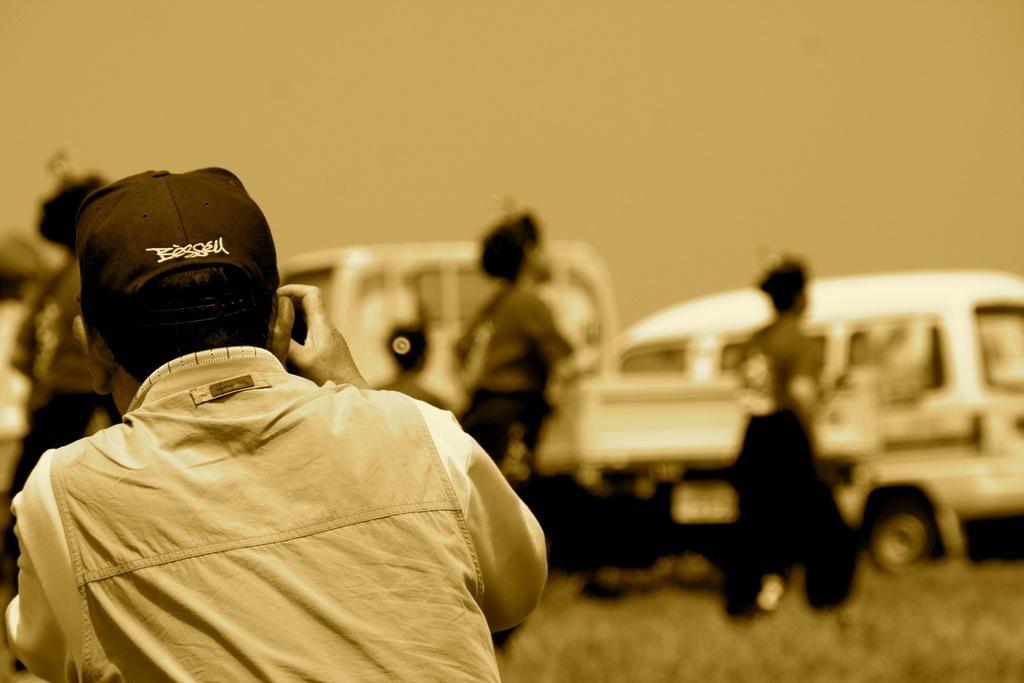Can you describe this image briefly? It is an edited image. In this image we can see a person wearing the cap and holding an object. In the background we can see the persons and also vehicles and grass. Sky is also visible. 